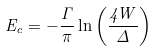Convert formula to latex. <formula><loc_0><loc_0><loc_500><loc_500>E _ { c } = - \frac { \Gamma } { \pi } \ln \left ( \frac { 4 W } { \Delta } \right )</formula> 